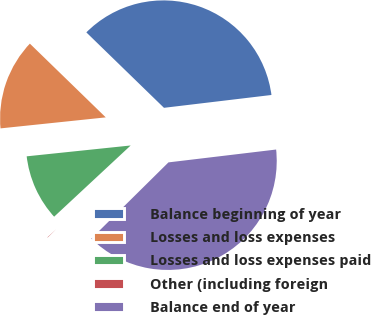<chart> <loc_0><loc_0><loc_500><loc_500><pie_chart><fcel>Balance beginning of year<fcel>Losses and loss expenses<fcel>Losses and loss expenses paid<fcel>Other (including foreign<fcel>Balance end of year<nl><fcel>35.84%<fcel>13.93%<fcel>10.27%<fcel>0.48%<fcel>39.49%<nl></chart> 